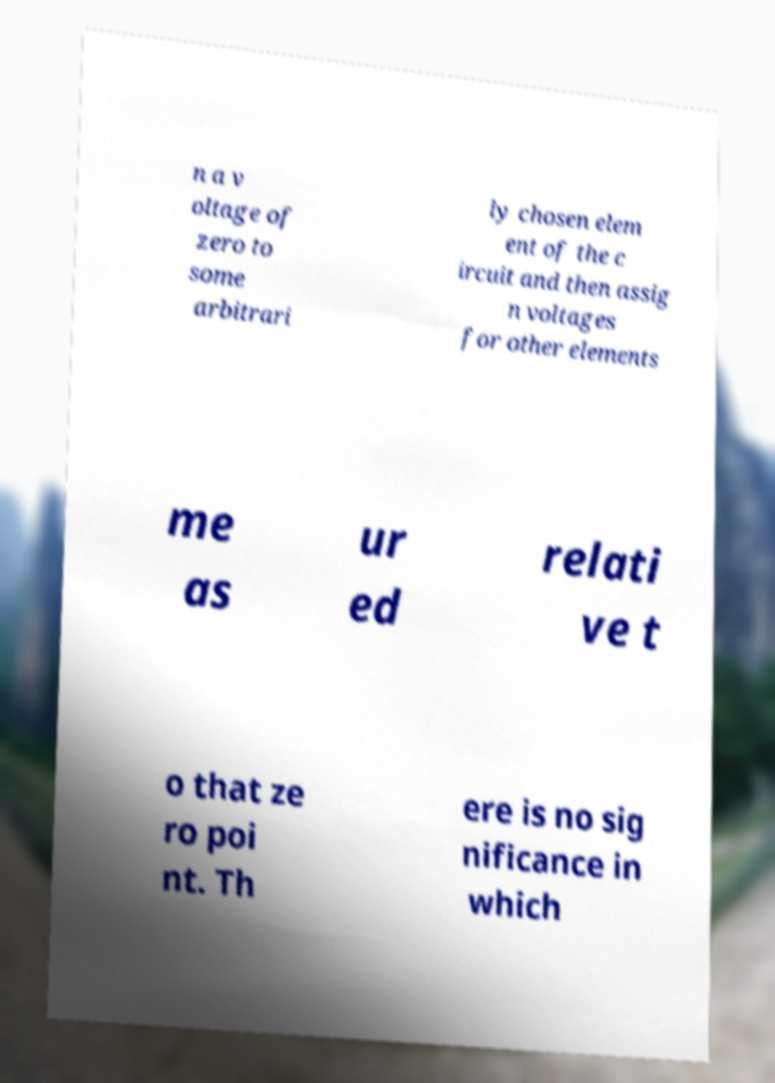I need the written content from this picture converted into text. Can you do that? n a v oltage of zero to some arbitrari ly chosen elem ent of the c ircuit and then assig n voltages for other elements me as ur ed relati ve t o that ze ro poi nt. Th ere is no sig nificance in which 